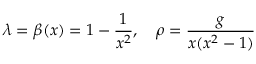Convert formula to latex. <formula><loc_0><loc_0><loc_500><loc_500>\lambda = \beta ( x ) = 1 - { \frac { 1 } { x ^ { 2 } } } , \quad \rho = { \frac { g } { x ( x ^ { 2 } - 1 ) } }</formula> 